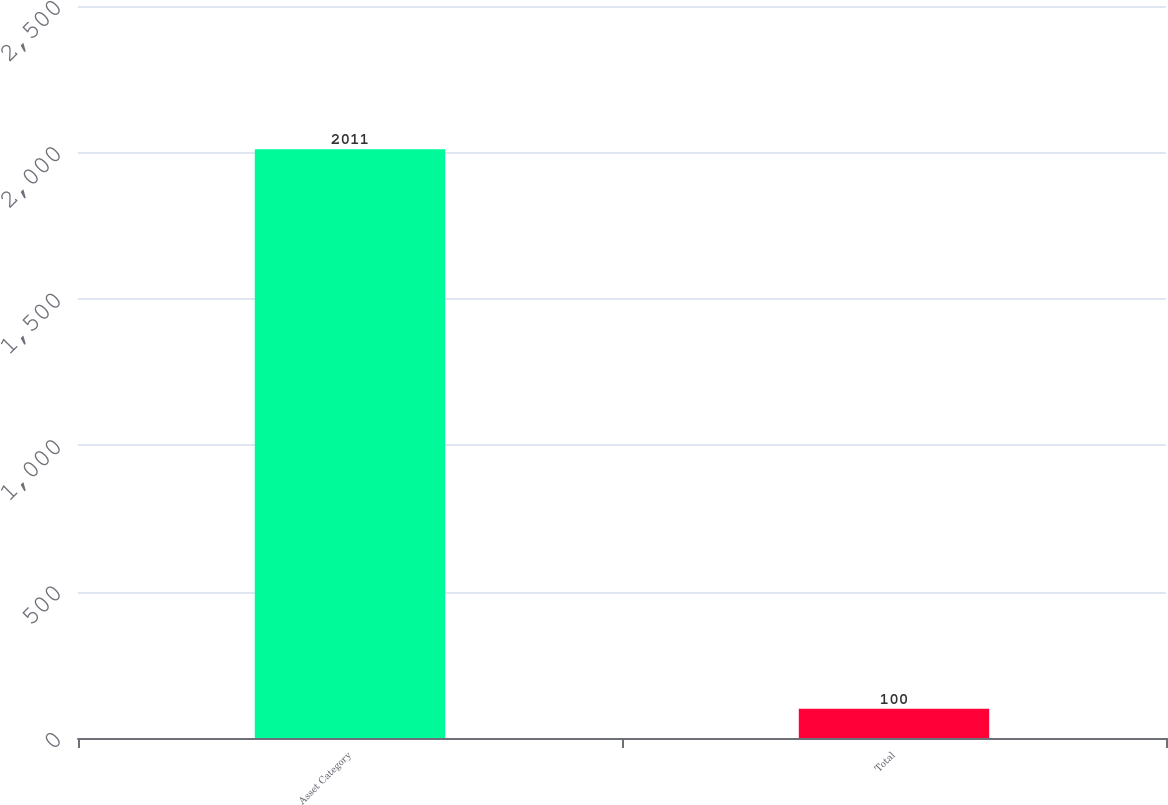Convert chart to OTSL. <chart><loc_0><loc_0><loc_500><loc_500><bar_chart><fcel>Asset Category<fcel>Total<nl><fcel>2011<fcel>100<nl></chart> 